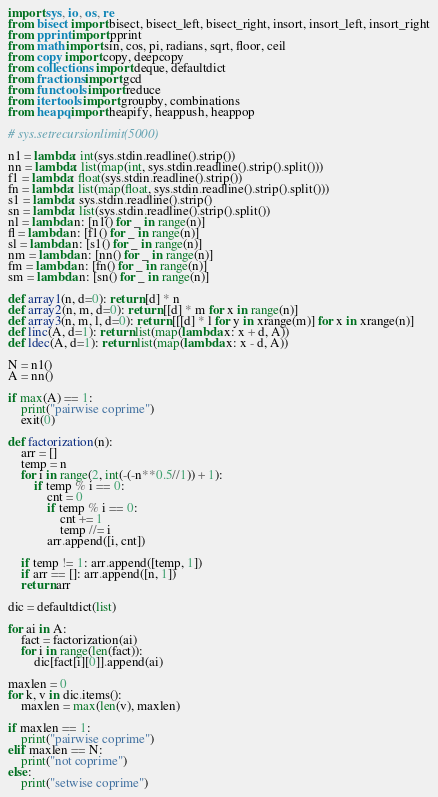Convert code to text. <code><loc_0><loc_0><loc_500><loc_500><_Python_>
import sys, io, os, re
from bisect import bisect, bisect_left, bisect_right, insort, insort_left, insort_right
from pprint import pprint
from math import sin, cos, pi, radians, sqrt, floor, ceil
from copy import copy, deepcopy
from collections import deque, defaultdict
from fractions import gcd
from functools import reduce
from itertools import groupby, combinations
from heapq import heapify, heappush, heappop

# sys.setrecursionlimit(5000)

n1 = lambda: int(sys.stdin.readline().strip())
nn = lambda: list(map(int, sys.stdin.readline().strip().split()))
f1 = lambda: float(sys.stdin.readline().strip())
fn = lambda: list(map(float, sys.stdin.readline().strip().split()))
s1 = lambda: sys.stdin.readline().strip()
sn = lambda: list(sys.stdin.readline().strip().split())
nl = lambda n: [n1() for _ in range(n)]
fl = lambda n: [f1() for _ in range(n)]
sl = lambda n: [s1() for _ in range(n)]
nm = lambda n: [nn() for _ in range(n)]
fm = lambda n: [fn() for _ in range(n)]
sm = lambda n: [sn() for _ in range(n)]

def array1(n, d=0): return [d] * n
def array2(n, m, d=0): return [[d] * m for x in range(n)]
def array3(n, m, l, d=0): return [[[d] * l for y in xrange(m)] for x in xrange(n)]
def linc(A, d=1): return list(map(lambda x: x + d, A))
def ldec(A, d=1): return list(map(lambda x: x - d, A))

N = n1()
A = nn()

if max(A) == 1:
    print("pairwise coprime")
    exit(0)

def factorization(n):
    arr = []
    temp = n
    for i in range(2, int(-(-n**0.5//1)) + 1):
        if temp % i == 0:
            cnt = 0
            if temp % i == 0:
                cnt += 1
                temp //= i
            arr.append([i, cnt])

    if temp != 1: arr.append([temp, 1])
    if arr == []: arr.append([n, 1])
    return arr

dic = defaultdict(list)

for ai in A:
    fact = factorization(ai)
    for i in range(len(fact)):
        dic[fact[i][0]].append(ai)

maxlen = 0
for k, v in dic.items():
    maxlen = max(len(v), maxlen)

if maxlen == 1:
    print("pairwise coprime")
elif maxlen == N:
    print("not coprime")
else:
    print("setwise coprime")
</code> 